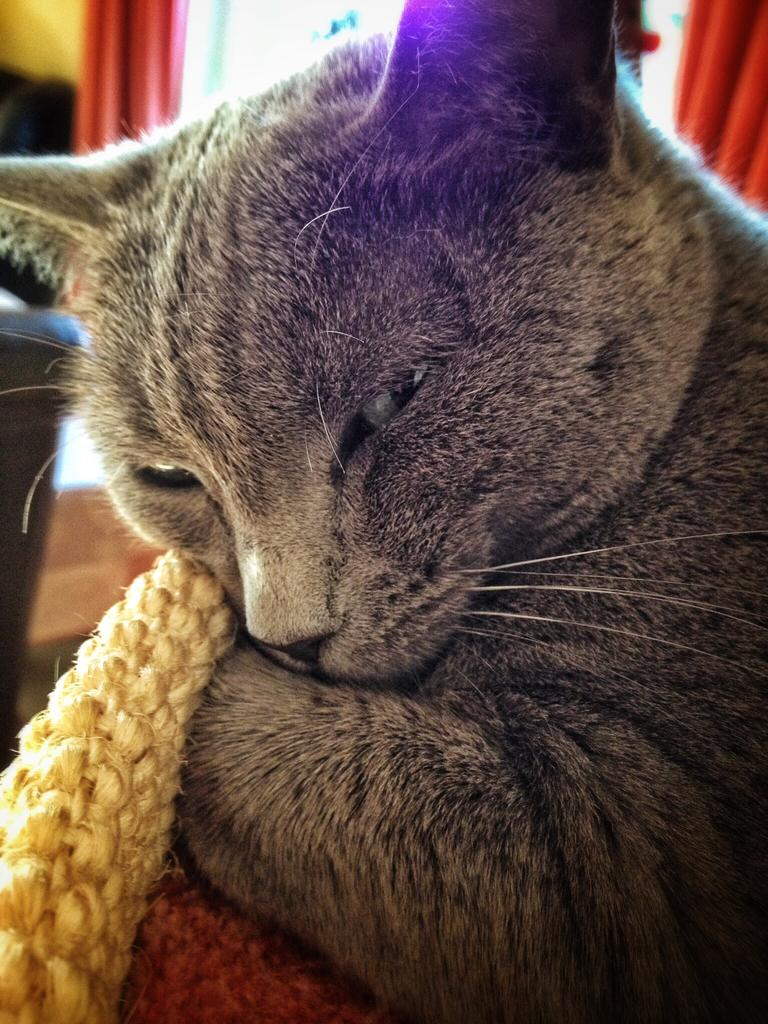What type of animal is in the image? There is a cat in the image. What colors can be seen on the cat? The cat has brown and gray colors. What type of furniture is in the background of the image? There is a couch in the background of the image. What color is the couch? The couch is black in color. What type of window treatment is in the background of the image? There is a curtain in the background of the image. What color is the curtain? The curtain is red in color. What color is the wall in the background of the image? The wall in the background of the image is yellow in color. What type of bushes can be seen growing near the cat in the image? There are no bushes visible in the image; it only features a cat, a couch, a curtain, and a yellow wall. What is the cat's tendency to jump on the sofa in the image? The image does not show the cat's tendency to jump on the sofa, nor is there a sofa present in the image. 